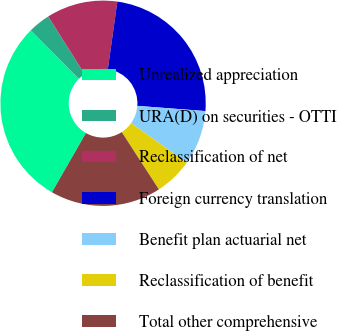Convert chart. <chart><loc_0><loc_0><loc_500><loc_500><pie_chart><fcel>Unrealized appreciation<fcel>URA(D) on securities - OTTI<fcel>Reclassification of net<fcel>Foreign currency translation<fcel>Benefit plan actuarial net<fcel>Reclassification of benefit<fcel>Total other comprehensive<nl><fcel>29.28%<fcel>3.45%<fcel>11.2%<fcel>23.99%<fcel>8.61%<fcel>6.03%<fcel>17.44%<nl></chart> 